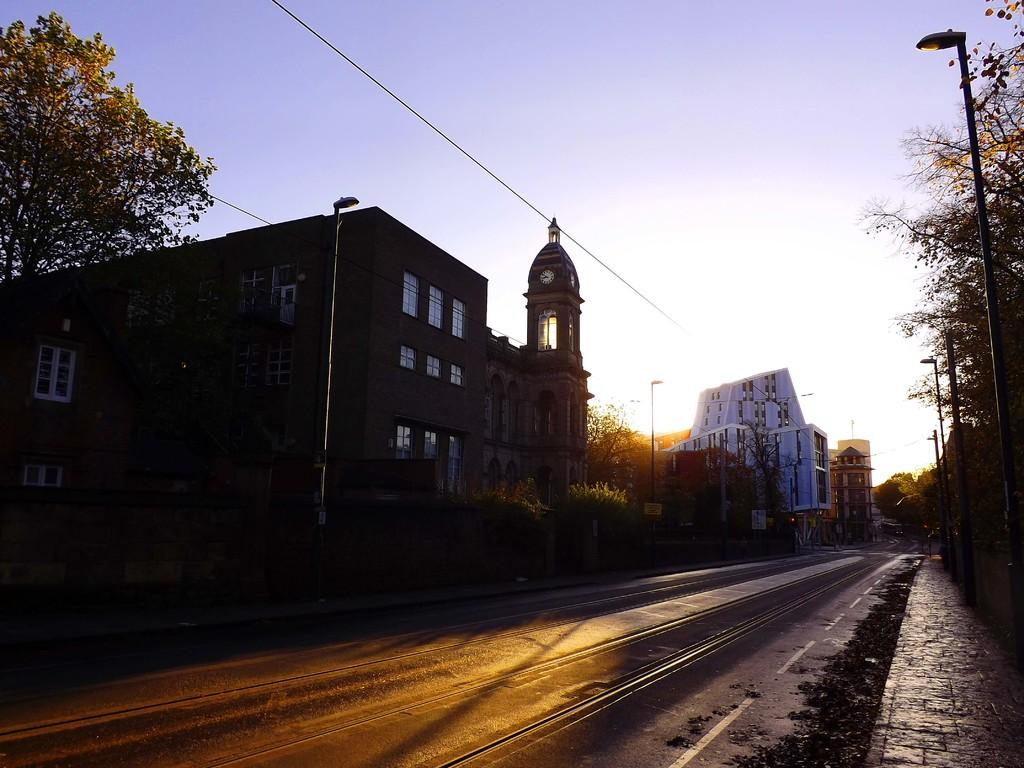What type of path can be seen in the image? There is a footpath in the image. What else is present alongside the footpath? There is a road in the image. What natural elements are visible in the image? There are trees in the image. What man-made structures can be seen in the image? There are buildings with windows in the image. What utility infrastructure is present in the image? There are wires and light poles in the image. What is visible in the background of the image? The sky is visible in the background of the image. What type of glass is being used to cover the trees in the image? There is no glass present in the image; it features a road, footpath, trees, wires, light poles, buildings, and the sky. What type of veil is being used to cover the light poles in the image? There is no veil present in the image; it features a road, footpath, trees, wires, light poles, buildings, and the sky. 